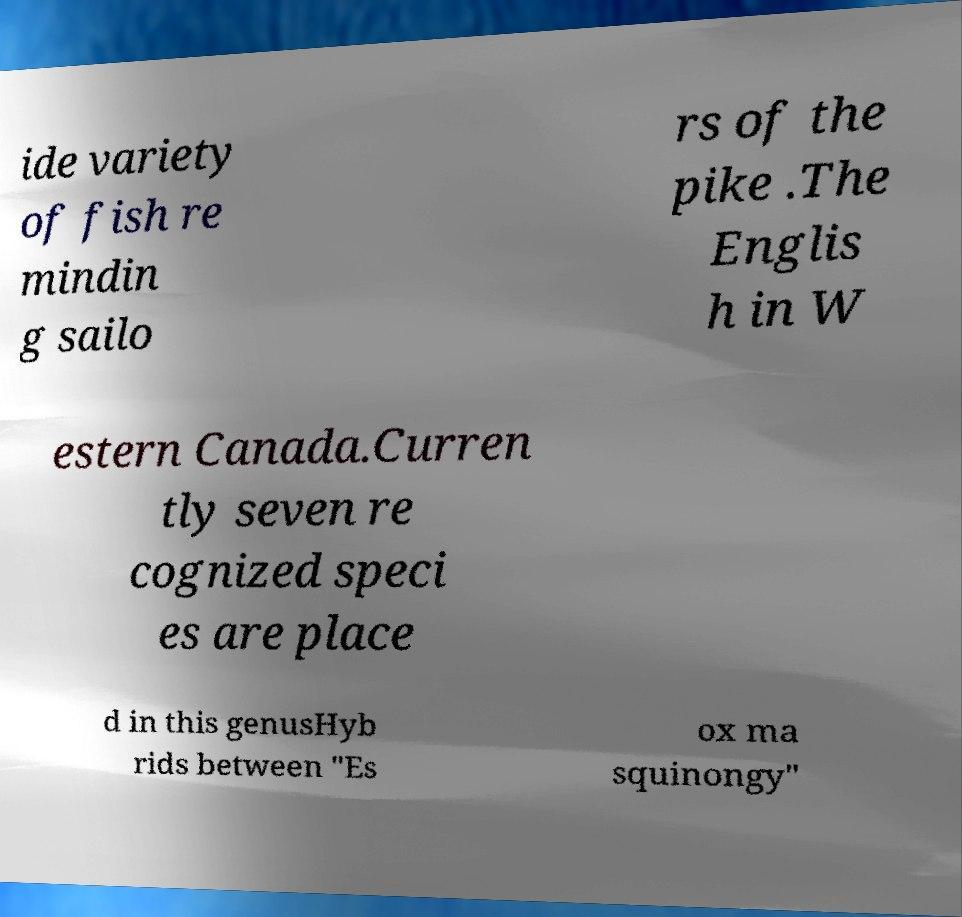Could you extract and type out the text from this image? ide variety of fish re mindin g sailo rs of the pike .The Englis h in W estern Canada.Curren tly seven re cognized speci es are place d in this genusHyb rids between "Es ox ma squinongy" 